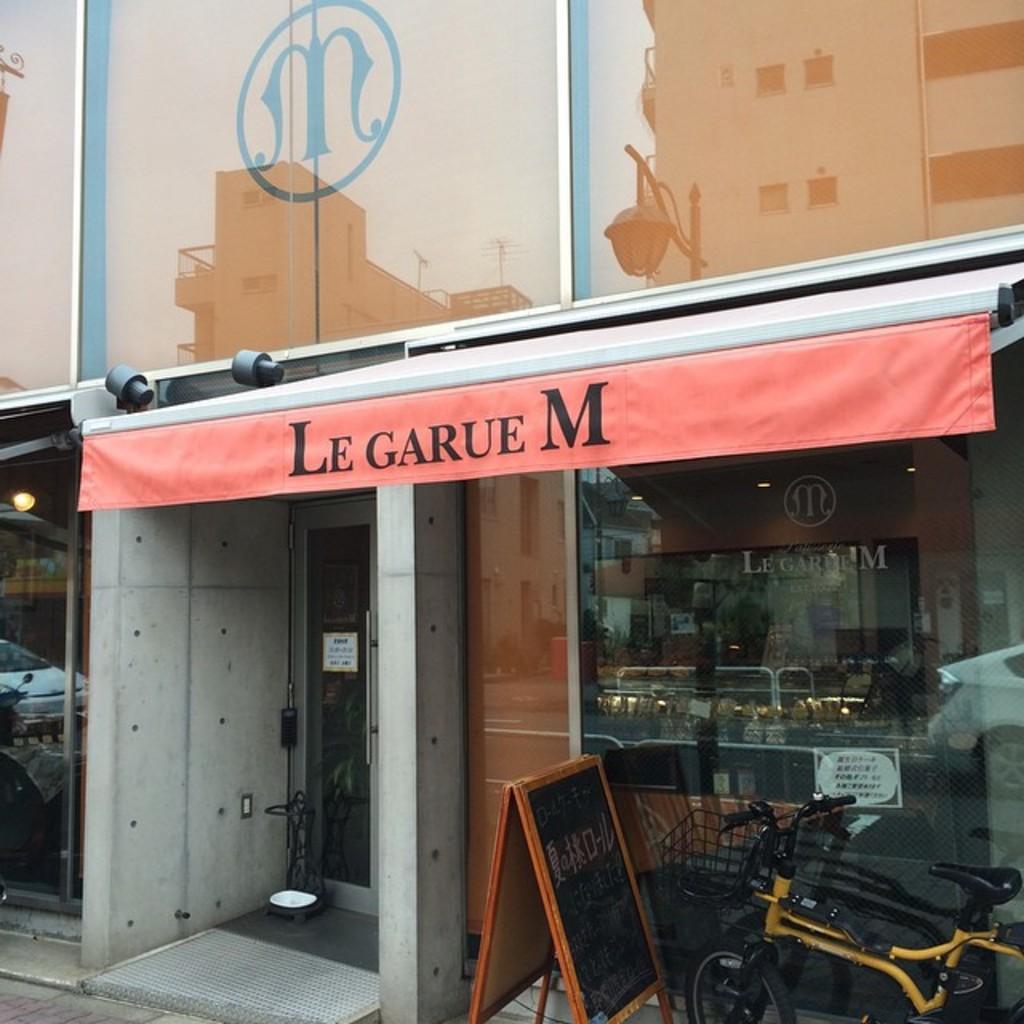Please provide a concise description of this image. In this image there is a building and we can see a store. At the bottom there is a board and a bicycle. 